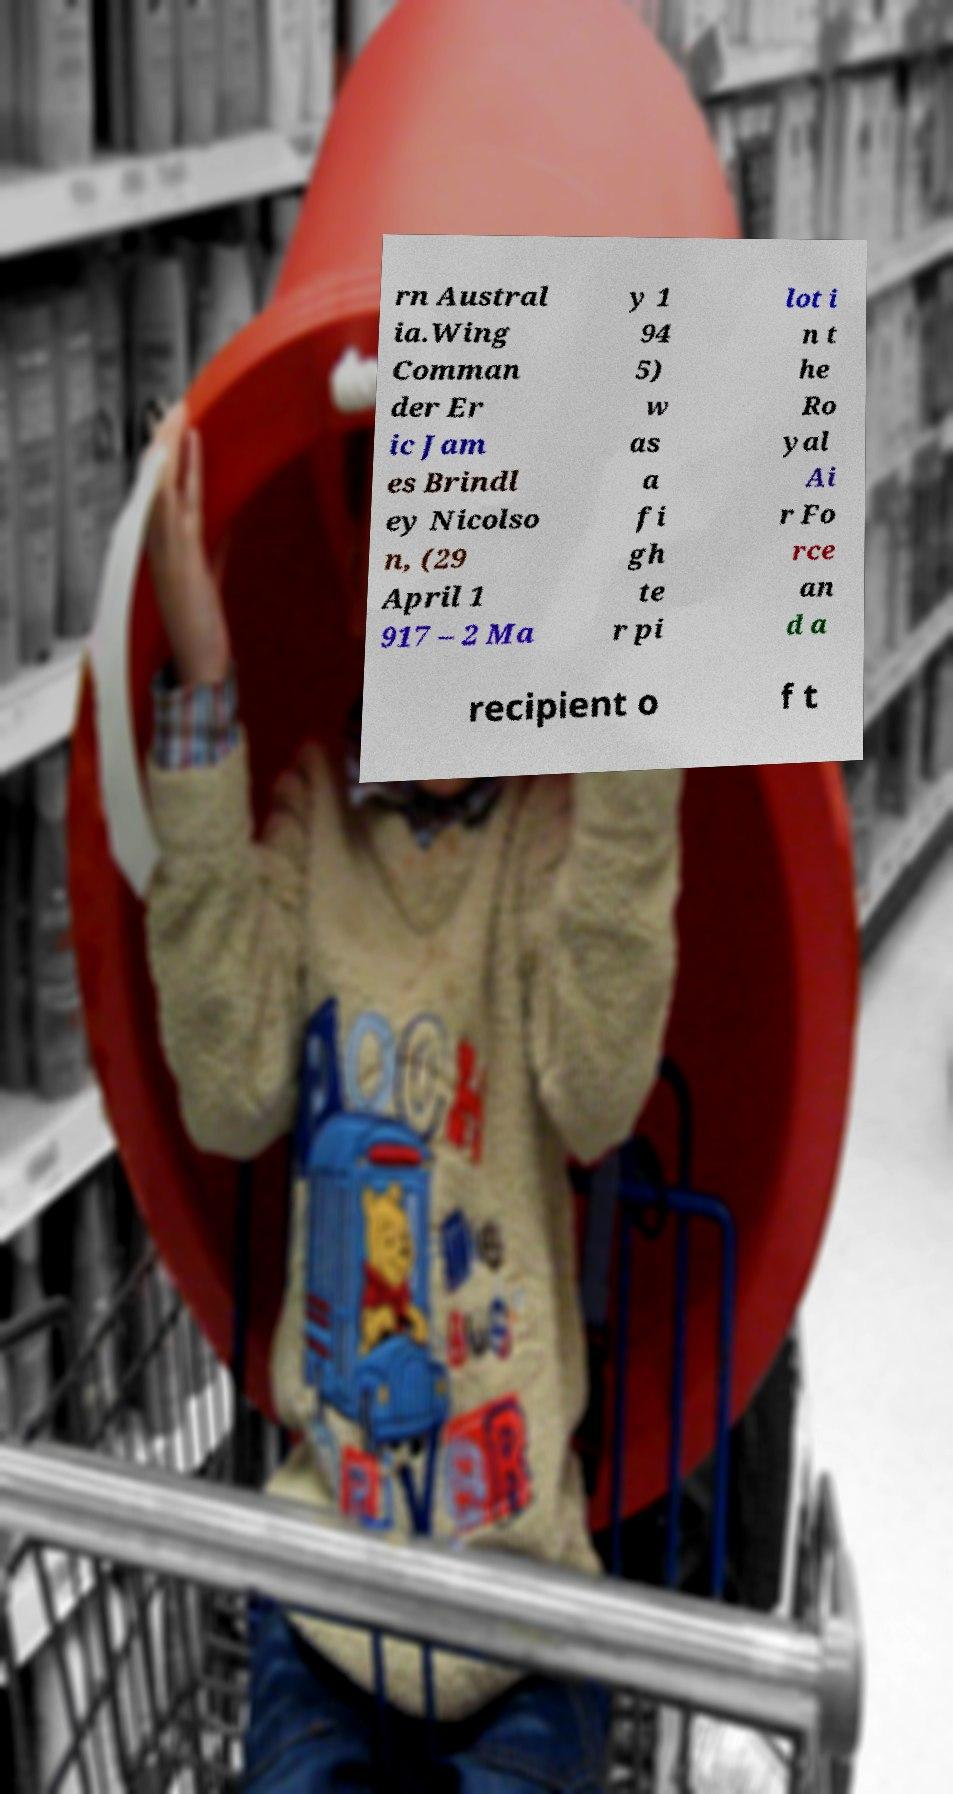Can you read and provide the text displayed in the image?This photo seems to have some interesting text. Can you extract and type it out for me? rn Austral ia.Wing Comman der Er ic Jam es Brindl ey Nicolso n, (29 April 1 917 – 2 Ma y 1 94 5) w as a fi gh te r pi lot i n t he Ro yal Ai r Fo rce an d a recipient o f t 